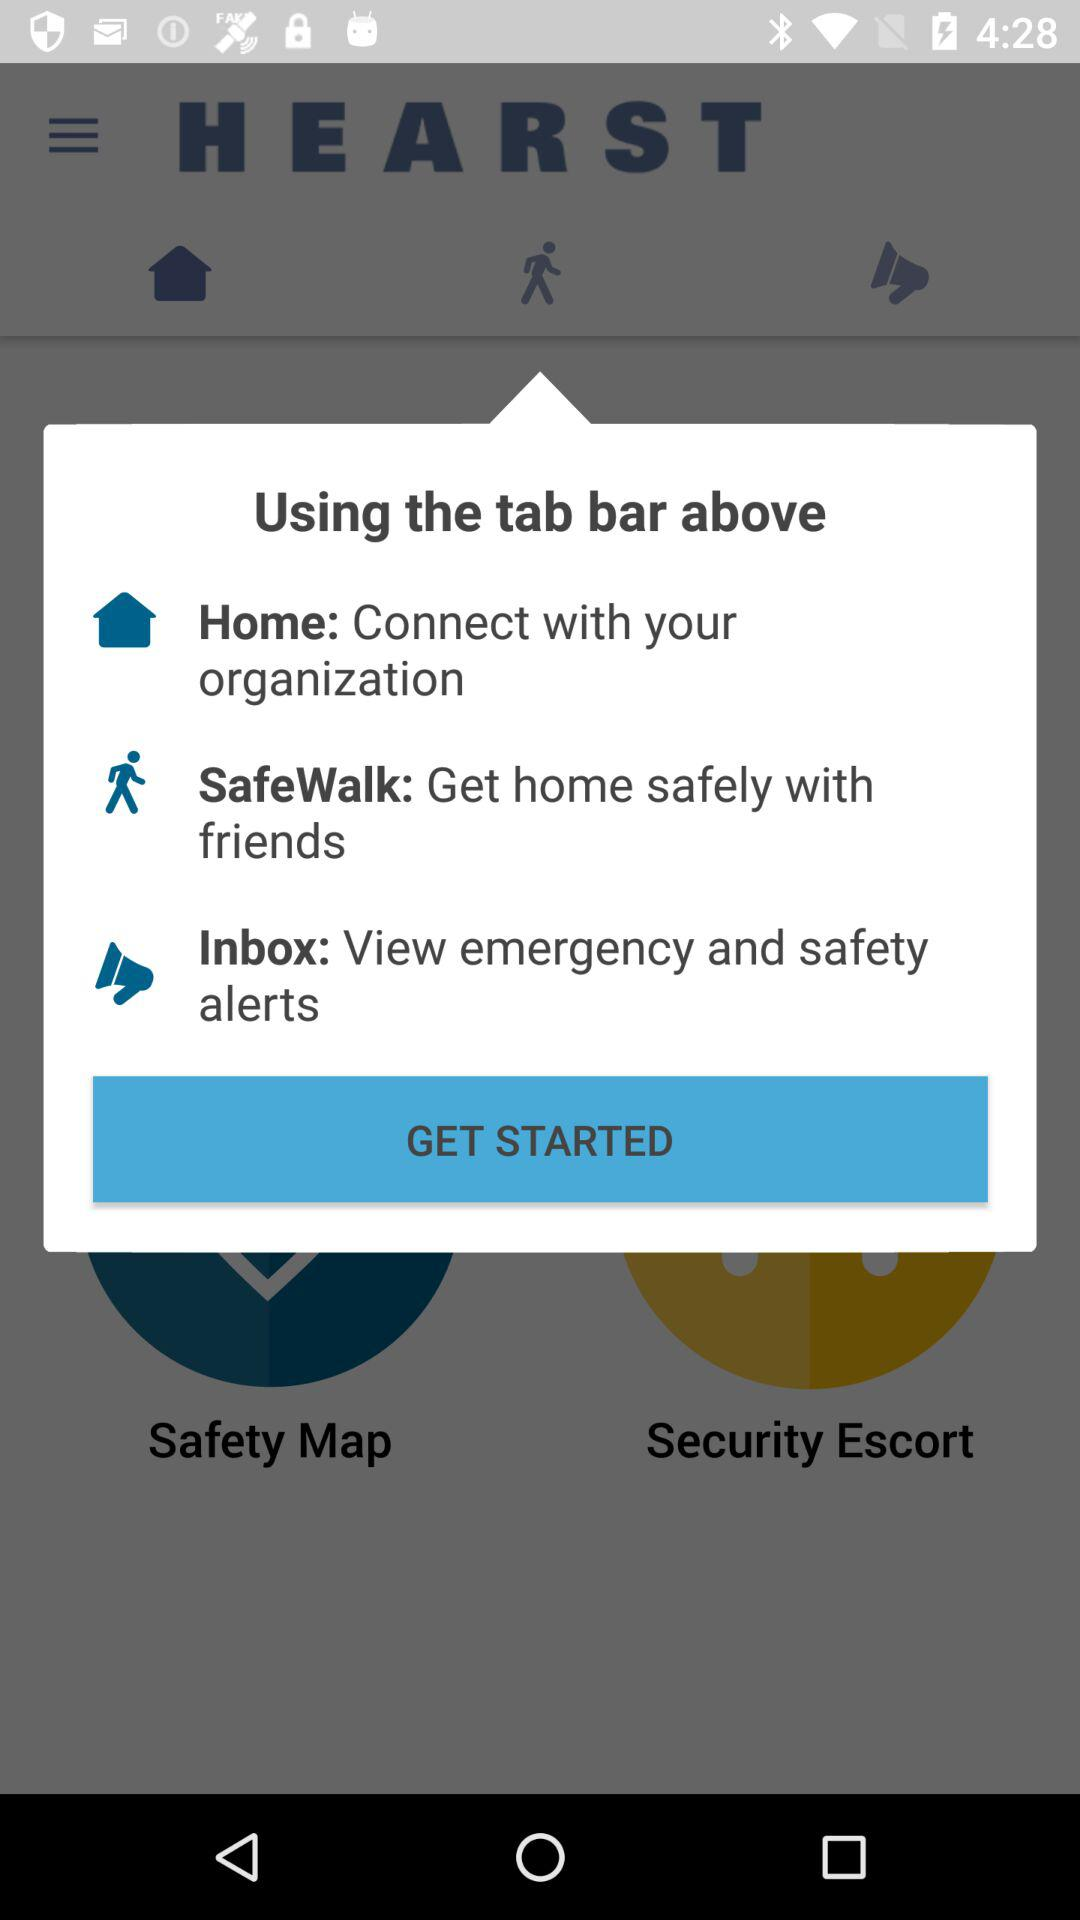What kind of information is for "Home"? The information is "Connect with your organization". 